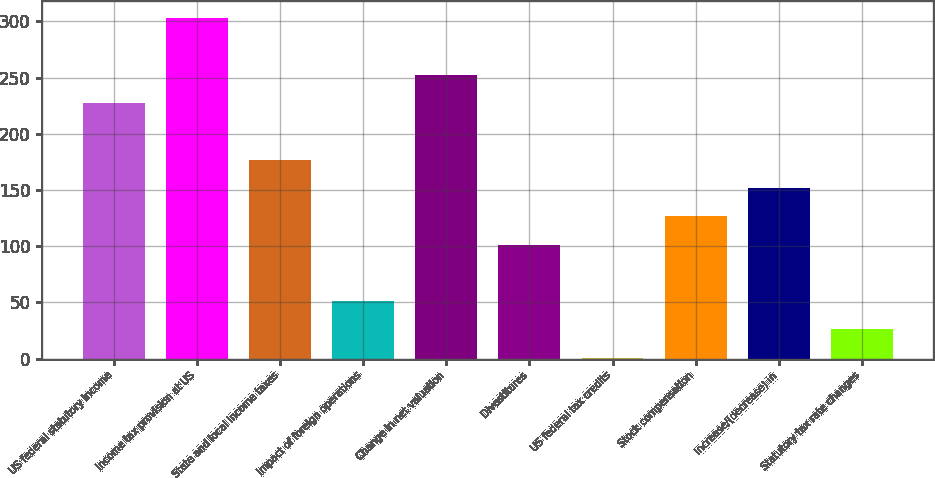<chart> <loc_0><loc_0><loc_500><loc_500><bar_chart><fcel>US federal statutory income<fcel>Income tax provision at US<fcel>State and local income taxes<fcel>Impact of foreign operations<fcel>Change in net valuation<fcel>Divestitures<fcel>US federal tax credits<fcel>Stock compensation<fcel>Increase/(decrease) in<fcel>Statutory tax rate changes<nl><fcel>227.13<fcel>302.61<fcel>176.81<fcel>51.01<fcel>252.29<fcel>101.33<fcel>0.69<fcel>126.49<fcel>151.65<fcel>25.85<nl></chart> 